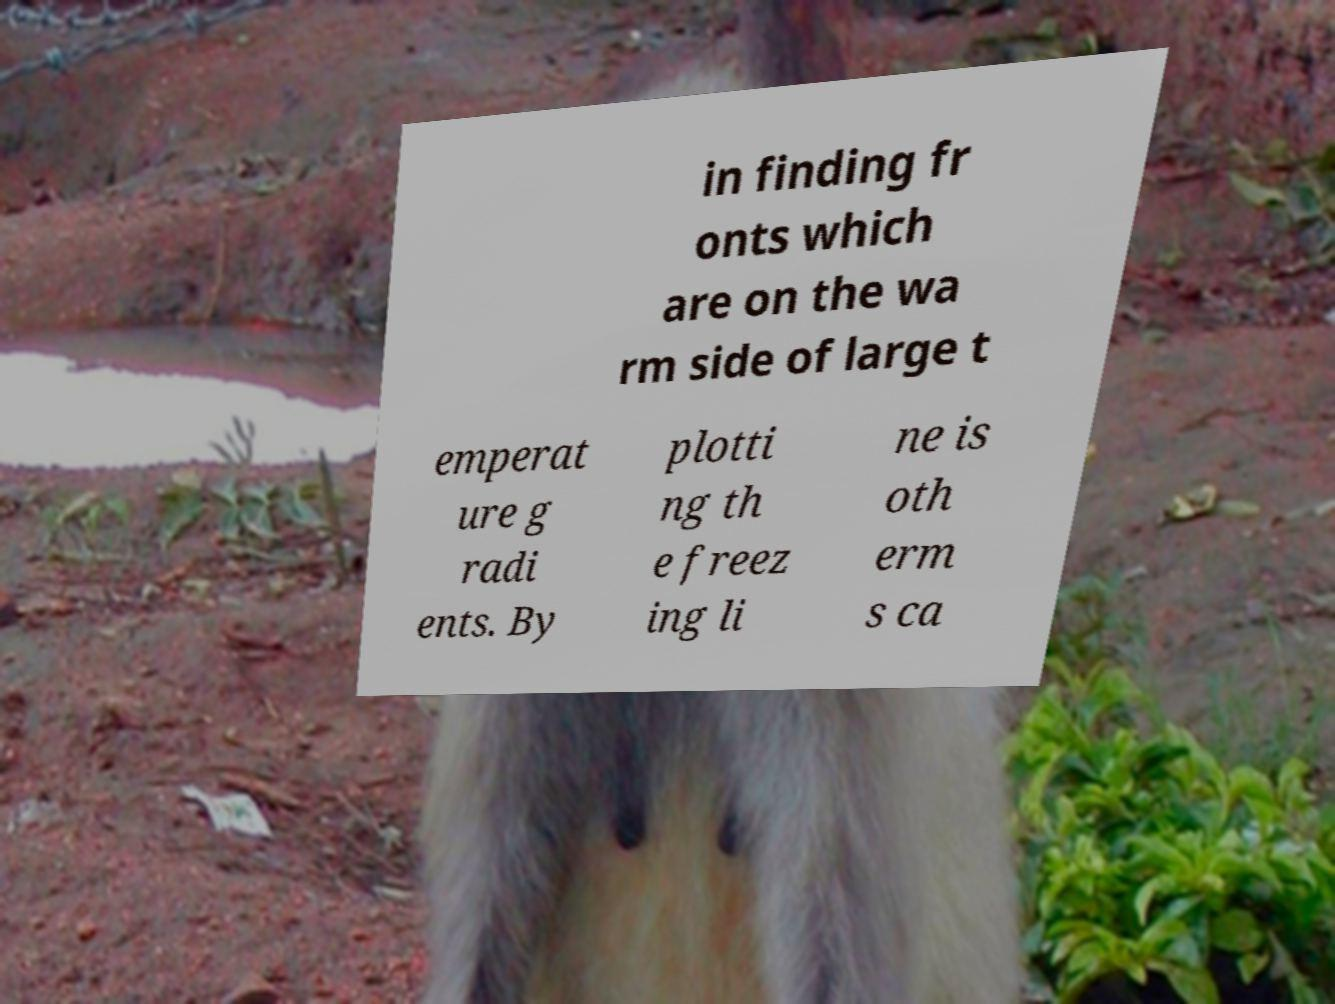Can you read and provide the text displayed in the image?This photo seems to have some interesting text. Can you extract and type it out for me? in finding fr onts which are on the wa rm side of large t emperat ure g radi ents. By plotti ng th e freez ing li ne is oth erm s ca 